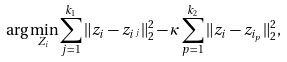<formula> <loc_0><loc_0><loc_500><loc_500>\arg \min _ { Z _ { i } } \sum _ { j = 1 } ^ { k _ { 1 } } \| z _ { i } - z _ { i ^ { j } } \| _ { 2 } ^ { 2 } - \kappa \sum _ { p = 1 } ^ { k _ { 2 } } \| z _ { i } - z _ { i _ { p } } \| _ { 2 } ^ { 2 } ,</formula> 